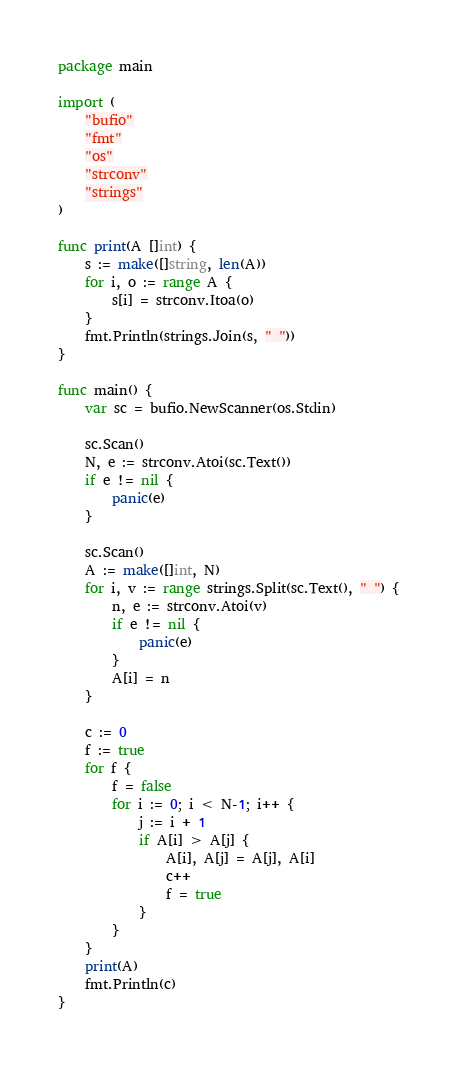Convert code to text. <code><loc_0><loc_0><loc_500><loc_500><_Go_>package main

import (
	"bufio"
	"fmt"
	"os"
	"strconv"
	"strings"
)

func print(A []int) {
	s := make([]string, len(A))
	for i, o := range A {
		s[i] = strconv.Itoa(o)
	}
	fmt.Println(strings.Join(s, " "))
}

func main() {
	var sc = bufio.NewScanner(os.Stdin)

	sc.Scan()
	N, e := strconv.Atoi(sc.Text())
	if e != nil {
		panic(e)
	}

	sc.Scan()
	A := make([]int, N)
	for i, v := range strings.Split(sc.Text(), " ") {
		n, e := strconv.Atoi(v)
		if e != nil {
			panic(e)
		}
		A[i] = n
	}

	c := 0
	f := true
	for f {
		f = false
		for i := 0; i < N-1; i++ {
			j := i + 1
			if A[i] > A[j] {
				A[i], A[j] = A[j], A[i]
				c++
				f = true
			}
		}
	}
	print(A)
	fmt.Println(c)
}
</code> 